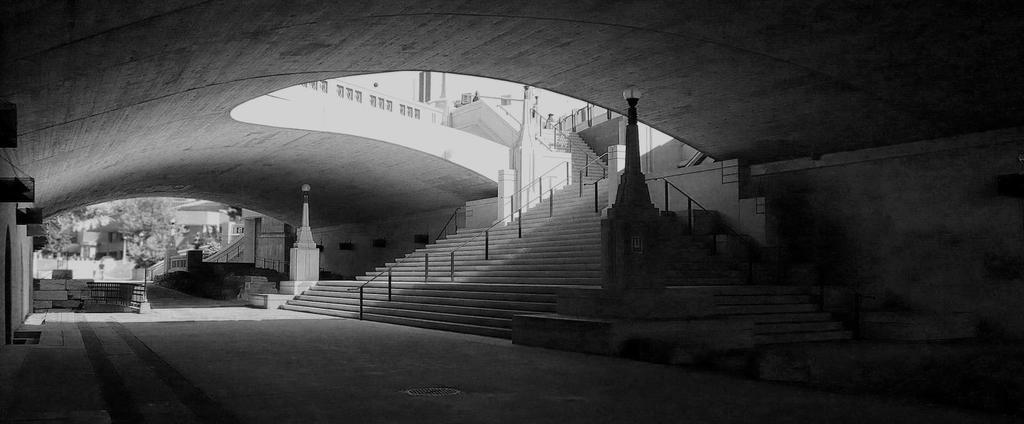What type of structure is present in the image? There is a house in the image. What can be seen inside the house? A staircase is visible in the image. What is providing illumination in the image? There are lights visible in the image. What type of vegetation is on the left side of the image? Trees are present on the left side of the image. What type of beef is being served at the table in the image? There is no table or beef present in the image. What kind of trouble is the person in the image experiencing? There is no person or trouble present in the image. 